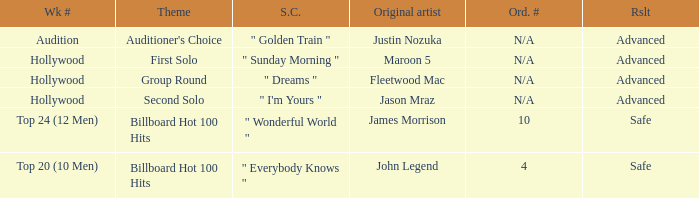What are all the topic wherein music preference is " golden train " Auditioner's Choice. 